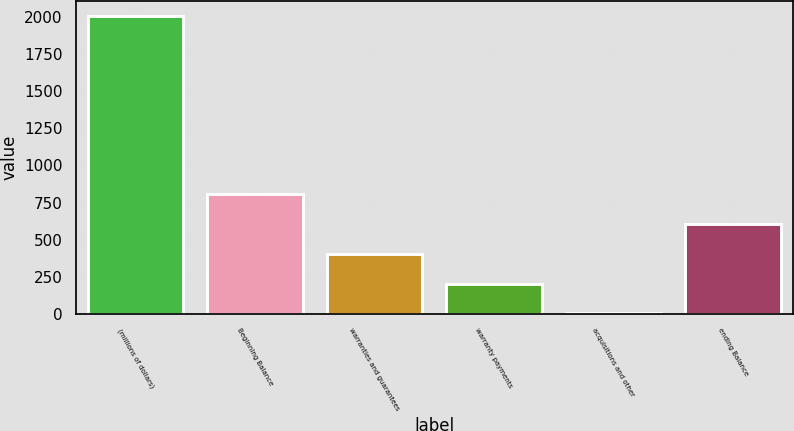Convert chart. <chart><loc_0><loc_0><loc_500><loc_500><bar_chart><fcel>(millions of dollars)<fcel>Beginning Balance<fcel>warranties and guarantees<fcel>warranty payments<fcel>acquisitions and other<fcel>ending Balance<nl><fcel>2007<fcel>805.38<fcel>404.84<fcel>204.57<fcel>4.3<fcel>605.11<nl></chart> 